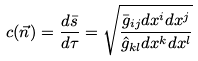Convert formula to latex. <formula><loc_0><loc_0><loc_500><loc_500>c ( \vec { n } ) = \frac { d \bar { s } } { d \tau } = \sqrt { \frac { \bar { g } _ { i j } d x ^ { i } d x ^ { j } } { \hat { g } _ { k l } d x ^ { k } d x ^ { l } } }</formula> 